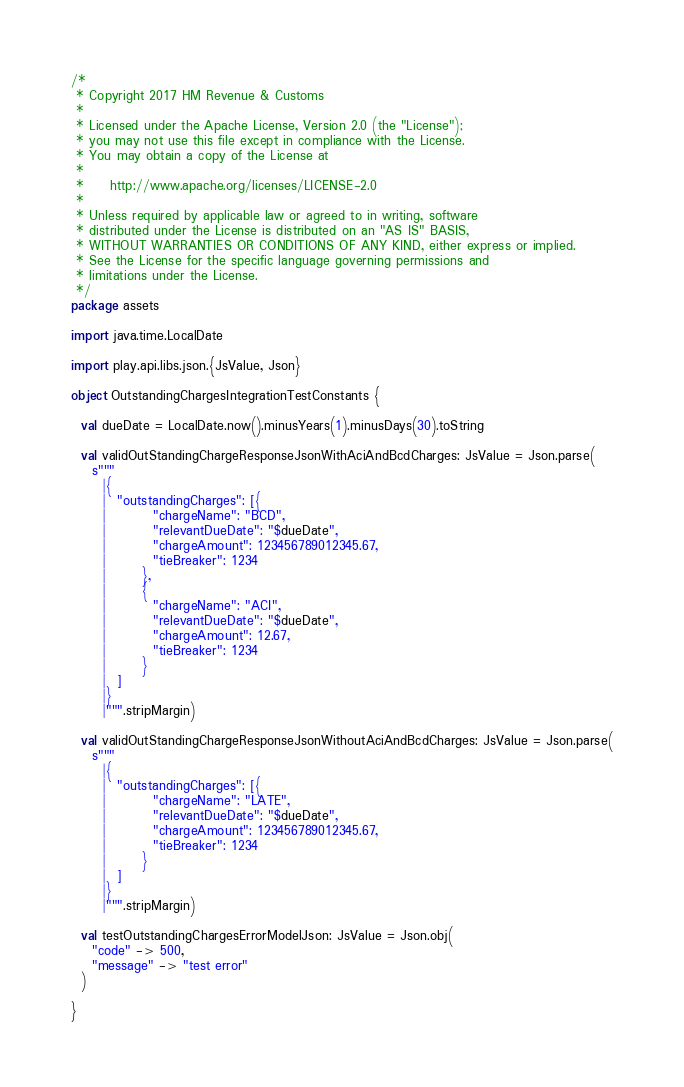<code> <loc_0><loc_0><loc_500><loc_500><_Scala_>/*
 * Copyright 2017 HM Revenue & Customs
 *
 * Licensed under the Apache License, Version 2.0 (the "License");
 * you may not use this file except in compliance with the License.
 * You may obtain a copy of the License at
 *
 *     http://www.apache.org/licenses/LICENSE-2.0
 *
 * Unless required by applicable law or agreed to in writing, software
 * distributed under the License is distributed on an "AS IS" BASIS,
 * WITHOUT WARRANTIES OR CONDITIONS OF ANY KIND, either express or implied.
 * See the License for the specific language governing permissions and
 * limitations under the License.
 */
package assets

import java.time.LocalDate

import play.api.libs.json.{JsValue, Json}

object OutstandingChargesIntegrationTestConstants {

  val dueDate = LocalDate.now().minusYears(1).minusDays(30).toString

  val validOutStandingChargeResponseJsonWithAciAndBcdCharges: JsValue = Json.parse(
    s"""
      |{
      |  "outstandingCharges": [{
      |         "chargeName": "BCD",
      |         "relevantDueDate": "$dueDate",
      |         "chargeAmount": 123456789012345.67,
      |         "tieBreaker": 1234
      |       },
      |       {
      |         "chargeName": "ACI",
      |         "relevantDueDate": "$dueDate",
      |         "chargeAmount": 12.67,
      |         "tieBreaker": 1234
      |       }
      |  ]
      |}
      |""".stripMargin)

  val validOutStandingChargeResponseJsonWithoutAciAndBcdCharges: JsValue = Json.parse(
    s"""
      |{
      |  "outstandingCharges": [{
      |         "chargeName": "LATE",
      |         "relevantDueDate": "$dueDate",
      |         "chargeAmount": 123456789012345.67,
      |         "tieBreaker": 1234
      |       }
      |  ]
      |}
      |""".stripMargin)

  val testOutstandingChargesErrorModelJson: JsValue = Json.obj(
    "code" -> 500,
    "message" -> "test error"
  )

}
</code> 